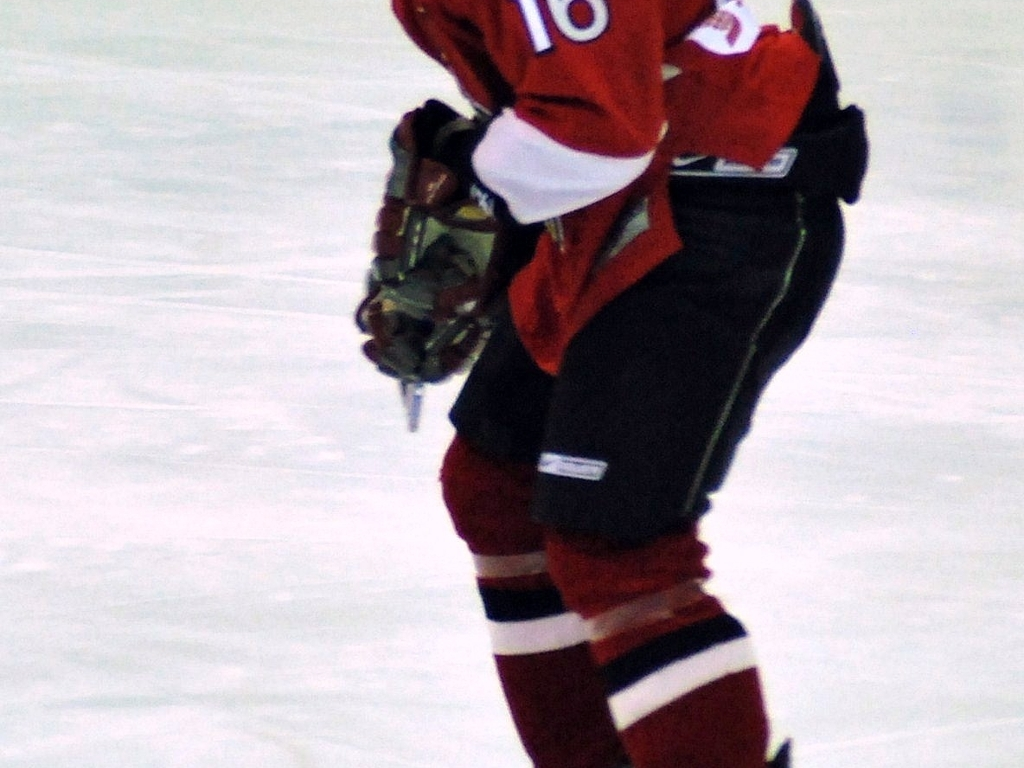What might be the environment or setting of this image? The environment appears to be an indoor ice rink, which is the typical setting for ice hockey games and practice sessions. 